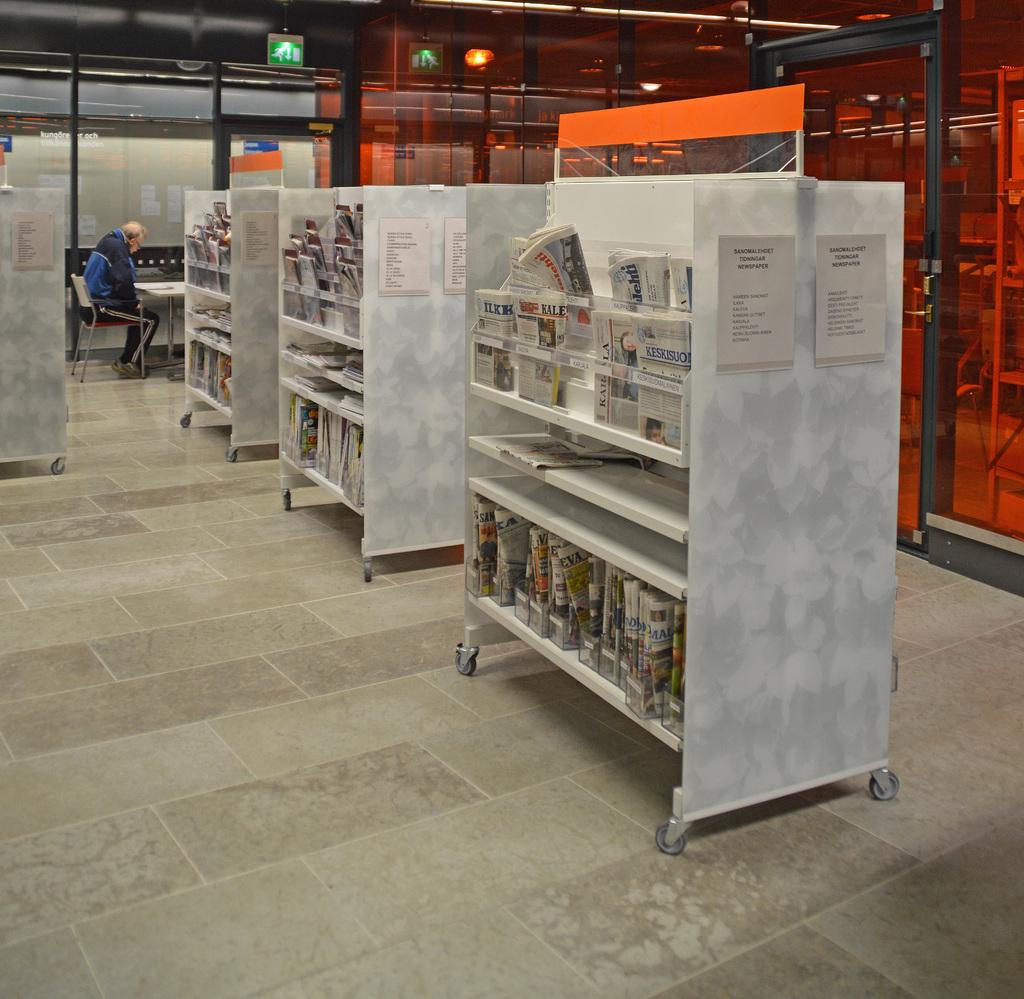<image>
Give a short and clear explanation of the subsequent image. A library with a movable shelf with a piece of paper that shows the text 'Sanomalehdet Tidnnigar Newspaper'. 